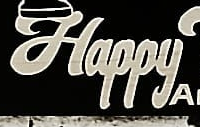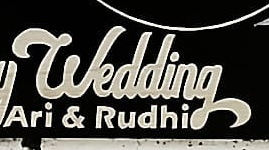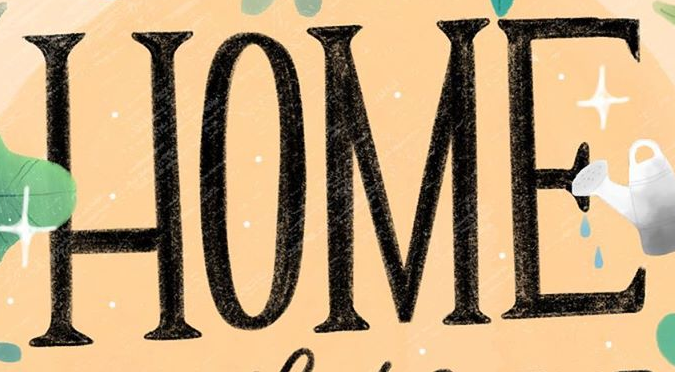What text is displayed in these images sequentially, separated by a semicolon? Happy; wedding; HOME 